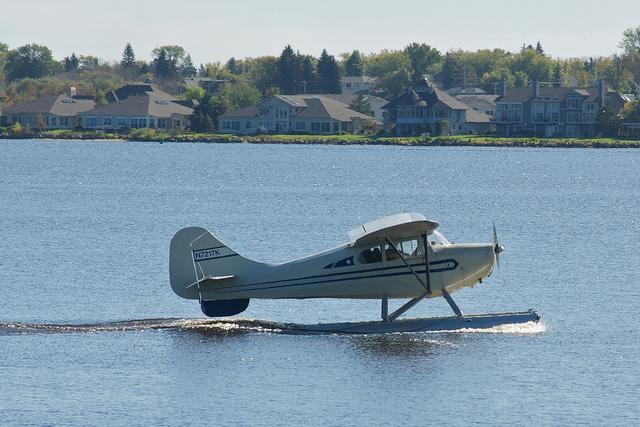What type of plane is this?
Answer briefly. Seaplane. Is this plane on a runway?
Concise answer only. No. Where is the plane?
Quick response, please. Water. 